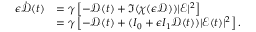<formula> <loc_0><loc_0><loc_500><loc_500>\begin{array} { r l } { \epsilon \dot { \mathcal { D } } ( t ) } & { = \gamma \left [ - \mathcal { D } ( t ) + \Im ( \chi ( \epsilon \mathcal { D } ) ) | \mathcal { E } | ^ { 2 } \right ] } \\ & { = \gamma \left [ - \mathcal { D } ( t ) + ( I _ { 0 } + \epsilon I _ { 1 } \mathcal { D } ( t ) ) | \mathcal { E } ( t ) | ^ { 2 } \right ] . } \end{array}</formula> 